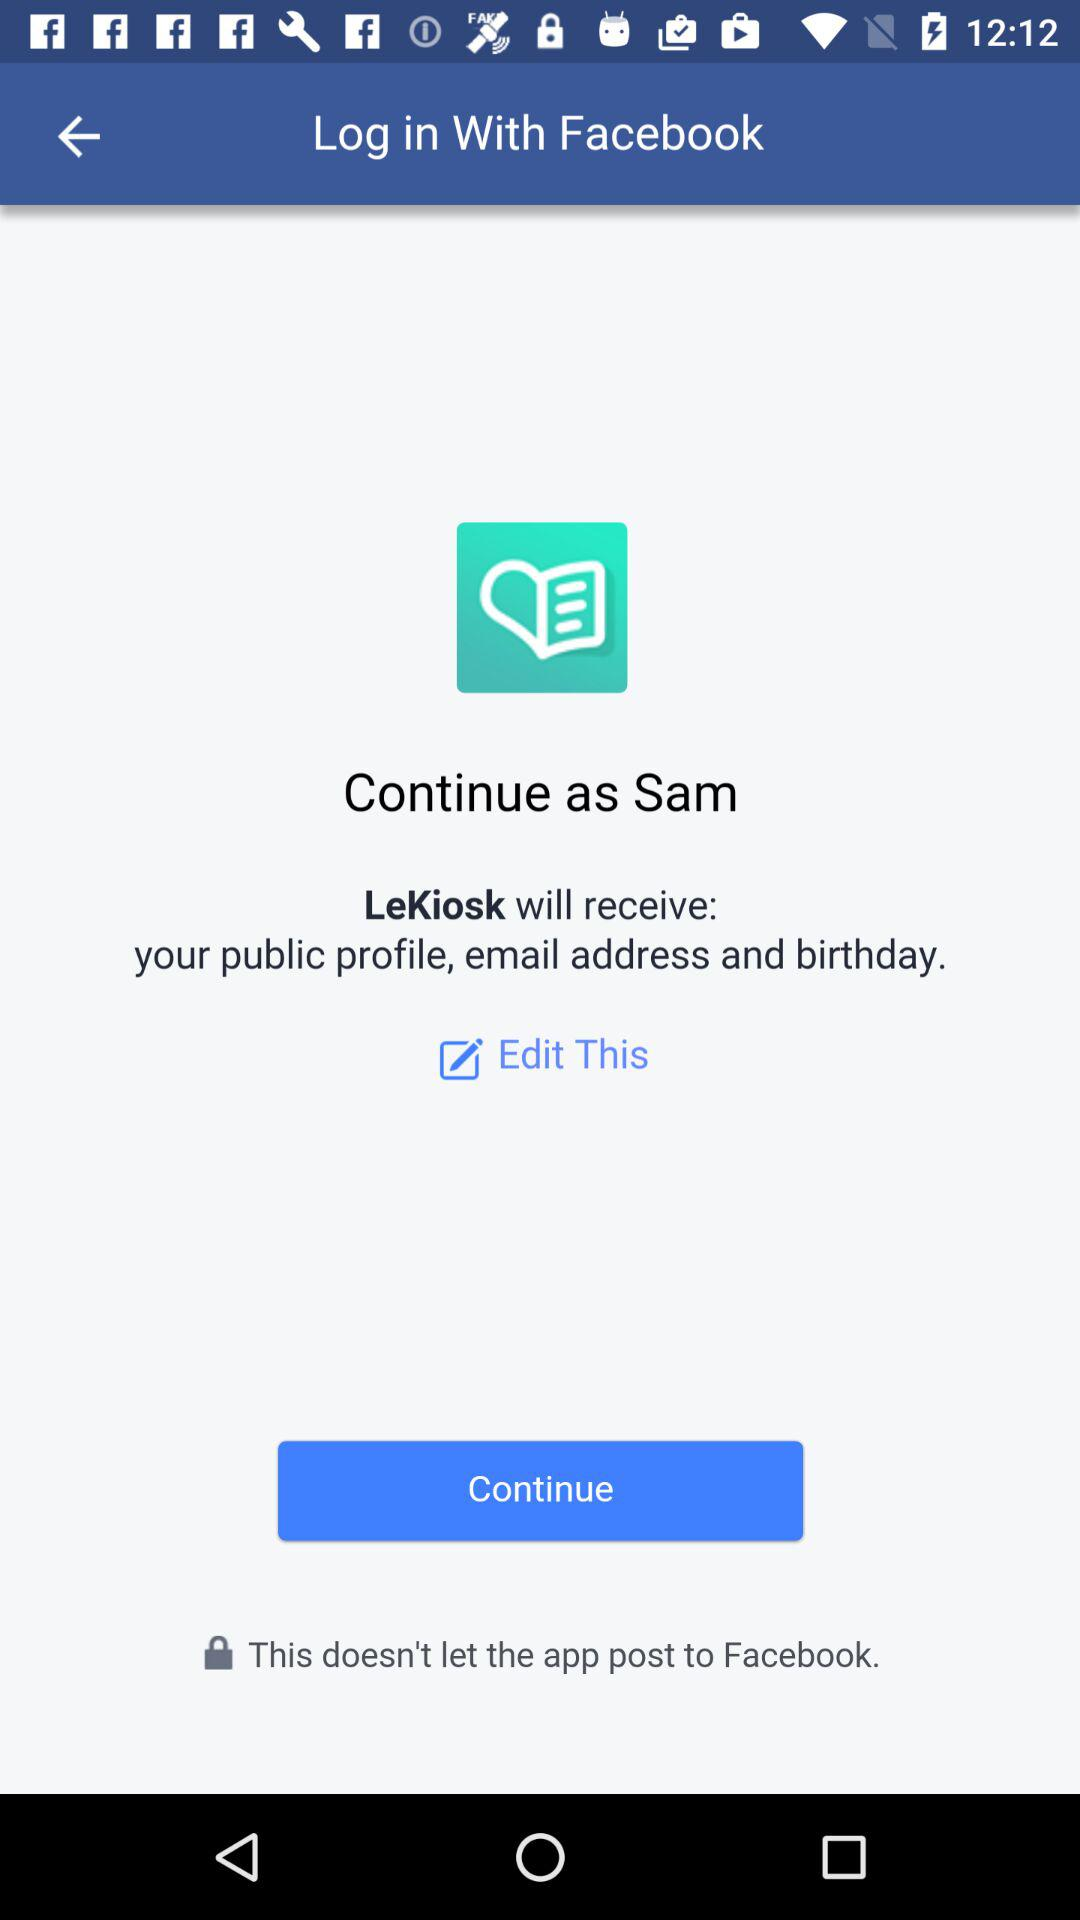What is the user name? The user name is Sam. 